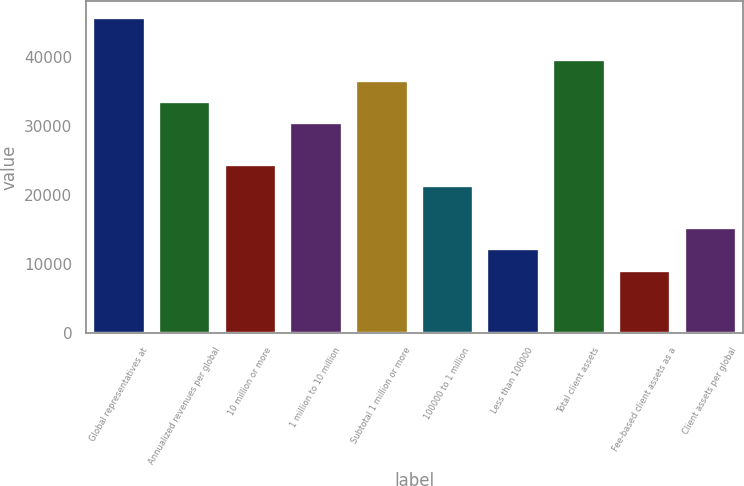Convert chart to OTSL. <chart><loc_0><loc_0><loc_500><loc_500><bar_chart><fcel>Global representatives at<fcel>Annualized revenues per global<fcel>10 million or more<fcel>1 million to 10 million<fcel>Subtotal 1 million or more<fcel>100000 to 1 million<fcel>Less than 100000<fcel>Total client assets<fcel>Fee-based client assets as a<fcel>Client assets per global<nl><fcel>45770.2<fcel>33565.3<fcel>24411.6<fcel>30514<fcel>36616.5<fcel>21360.3<fcel>12206.6<fcel>39667.8<fcel>9155.36<fcel>15257.8<nl></chart> 